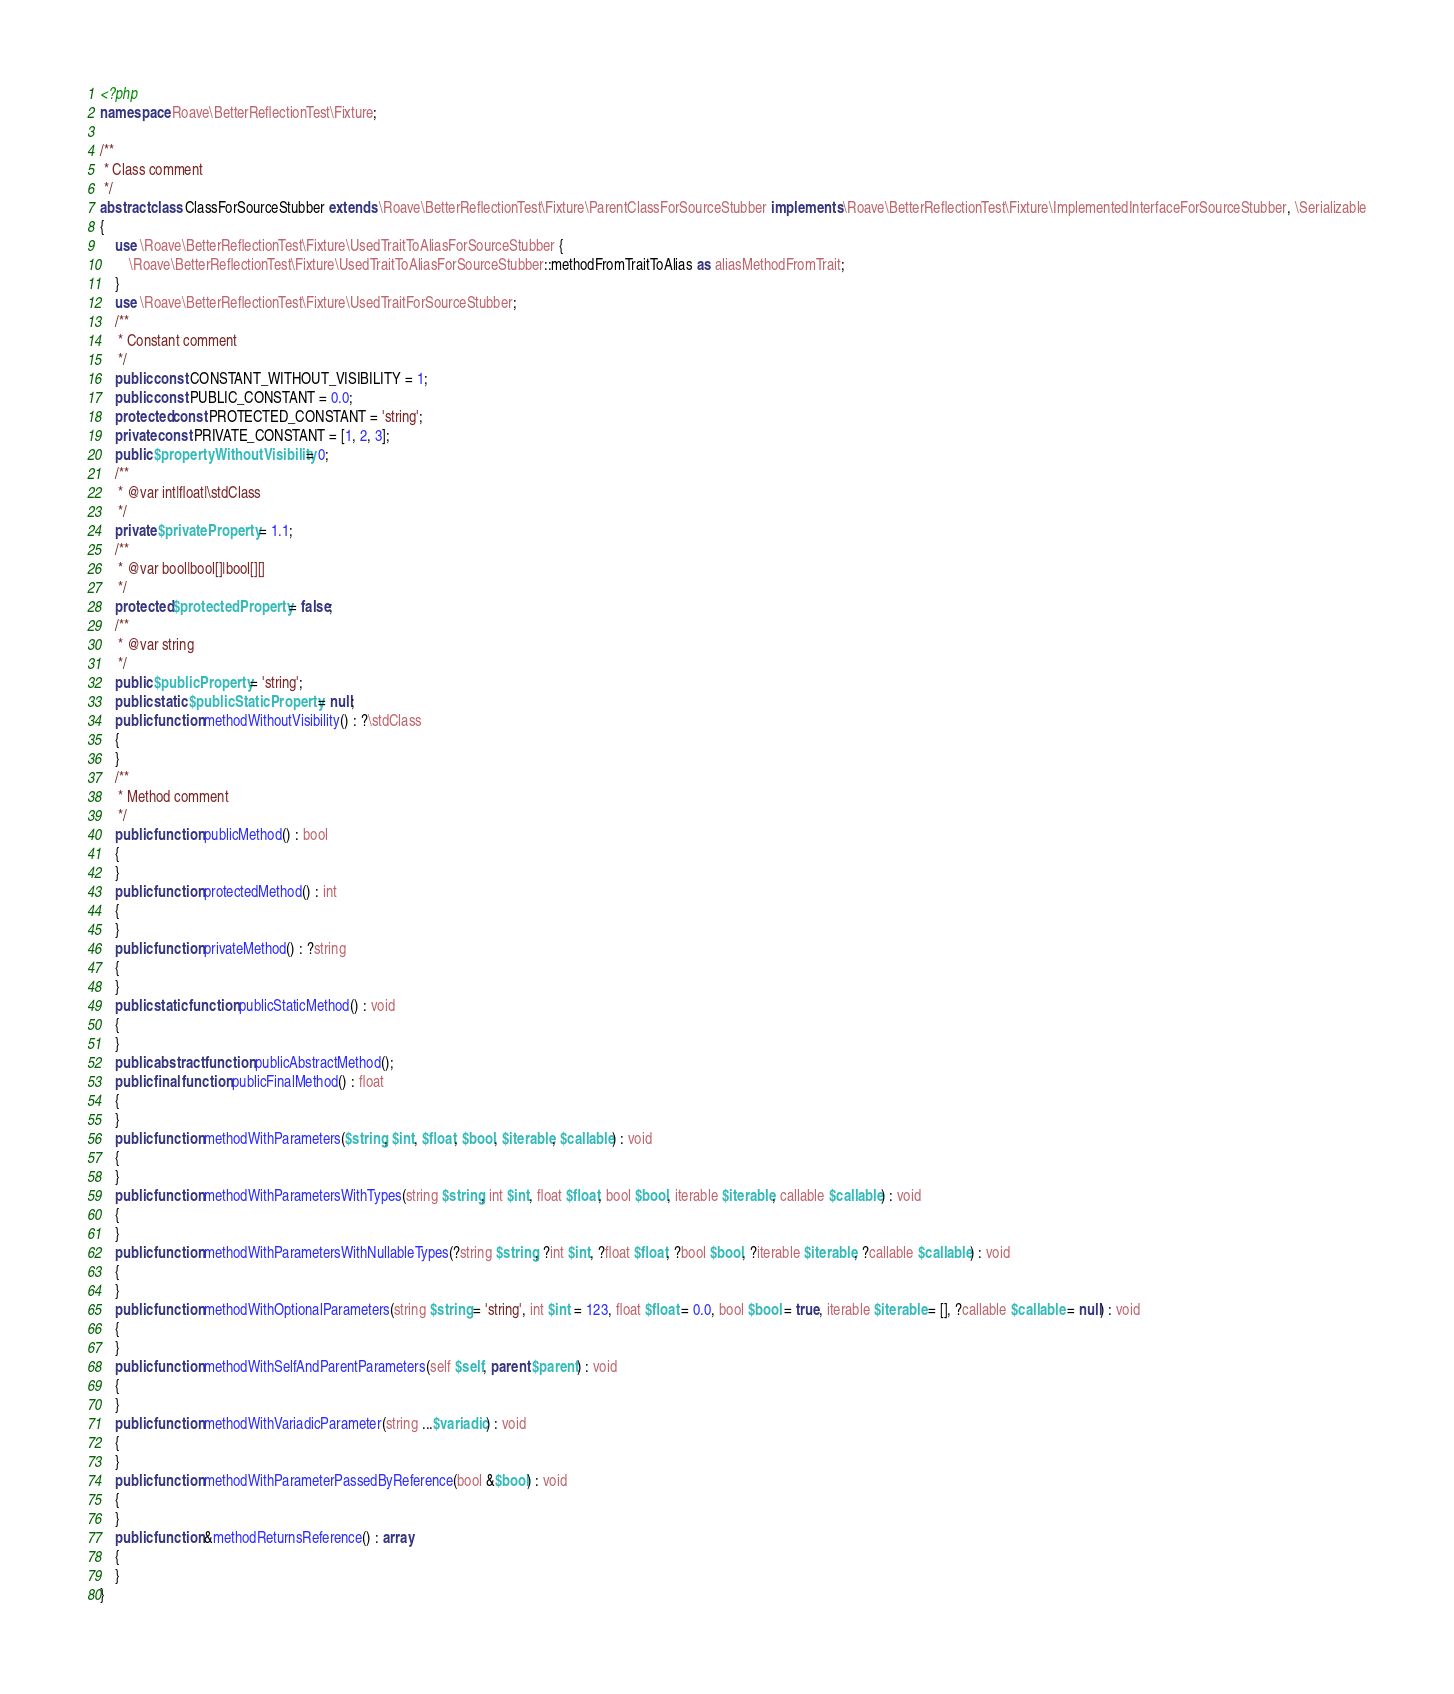<code> <loc_0><loc_0><loc_500><loc_500><_PHP_><?php
namespace Roave\BetterReflectionTest\Fixture;

/**
 * Class comment
 */
abstract class ClassForSourceStubber extends \Roave\BetterReflectionTest\Fixture\ParentClassForSourceStubber implements \Roave\BetterReflectionTest\Fixture\ImplementedInterfaceForSourceStubber, \Serializable
{
    use \Roave\BetterReflectionTest\Fixture\UsedTraitToAliasForSourceStubber {
        \Roave\BetterReflectionTest\Fixture\UsedTraitToAliasForSourceStubber::methodFromTraitToAlias as aliasMethodFromTrait;
    }
    use \Roave\BetterReflectionTest\Fixture\UsedTraitForSourceStubber;
    /**
     * Constant comment
     */
    public const CONSTANT_WITHOUT_VISIBILITY = 1;
    public const PUBLIC_CONSTANT = 0.0;
    protected const PROTECTED_CONSTANT = 'string';
    private const PRIVATE_CONSTANT = [1, 2, 3];
    public $propertyWithoutVisibility = 0;
    /**
     * @var int|float|\stdClass
     */
    private $privateProperty = 1.1;
    /**
     * @var bool|bool[]|bool[][]
     */
    protected $protectedProperty = false;
    /**
     * @var string
     */
    public $publicProperty = 'string';
    public static $publicStaticProperty = null;
    public function methodWithoutVisibility() : ?\stdClass
    {
    }
    /**
     * Method comment
     */
    public function publicMethod() : bool
    {
    }
    public function protectedMethod() : int
    {
    }
    public function privateMethod() : ?string
    {
    }
    public static function publicStaticMethod() : void
    {
    }
    public abstract function publicAbstractMethod();
    public final function publicFinalMethod() : float
    {
    }
    public function methodWithParameters($string, $int, $float, $bool, $iterable, $callable) : void
    {
    }
    public function methodWithParametersWithTypes(string $string, int $int, float $float, bool $bool, iterable $iterable, callable $callable) : void
    {
    }
    public function methodWithParametersWithNullableTypes(?string $string, ?int $int, ?float $float, ?bool $bool, ?iterable $iterable, ?callable $callable) : void
    {
    }
    public function methodWithOptionalParameters(string $string = 'string', int $int = 123, float $float = 0.0, bool $bool = true, iterable $iterable = [], ?callable $callable = null) : void
    {
    }
    public function methodWithSelfAndParentParameters(self $self, parent $parent) : void
    {
    }
    public function methodWithVariadicParameter(string ...$variadic) : void
    {
    }
    public function methodWithParameterPassedByReference(bool &$bool) : void
    {
    }
    public function &methodReturnsReference() : array
    {
    }
}
</code> 